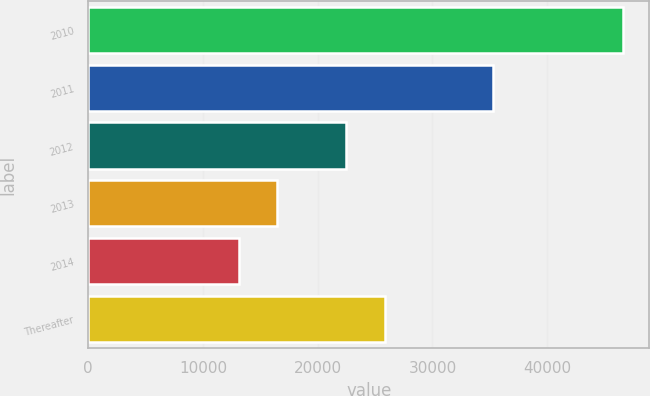<chart> <loc_0><loc_0><loc_500><loc_500><bar_chart><fcel>2010<fcel>2011<fcel>2012<fcel>2013<fcel>2014<fcel>Thereafter<nl><fcel>46570<fcel>35271<fcel>22499<fcel>16464.1<fcel>13119<fcel>25844.1<nl></chart> 